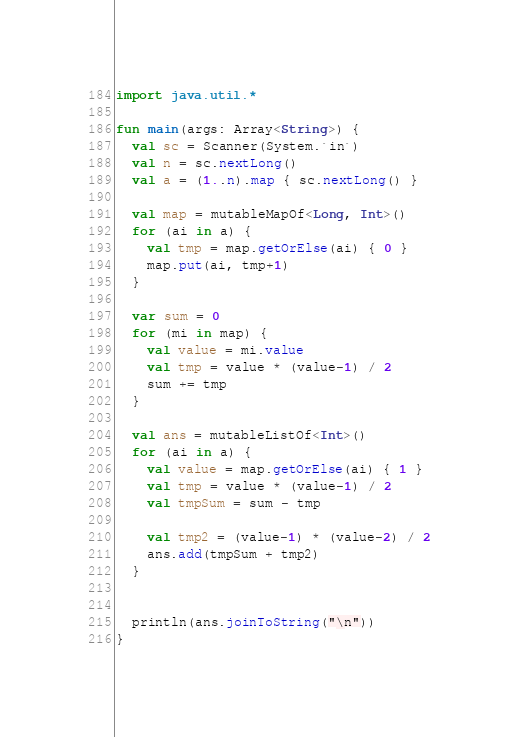<code> <loc_0><loc_0><loc_500><loc_500><_Kotlin_>import java.util.*

fun main(args: Array<String>) {
  val sc = Scanner(System.`in`)
  val n = sc.nextLong()
  val a = (1..n).map { sc.nextLong() }

  val map = mutableMapOf<Long, Int>()
  for (ai in a) {
    val tmp = map.getOrElse(ai) { 0 }
    map.put(ai, tmp+1)
  }

  var sum = 0
  for (mi in map) {
    val value = mi.value
    val tmp = value * (value-1) / 2
    sum += tmp
  }

  val ans = mutableListOf<Int>()
  for (ai in a) {
    val value = map.getOrElse(ai) { 1 }
    val tmp = value * (value-1) / 2
    val tmpSum = sum - tmp

    val tmp2 = (value-1) * (value-2) / 2
    ans.add(tmpSum + tmp2)
  }


  println(ans.joinToString("\n"))
}
</code> 